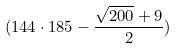Convert formula to latex. <formula><loc_0><loc_0><loc_500><loc_500>( 1 4 4 \cdot 1 8 5 - \frac { \sqrt { 2 0 0 } + 9 } { 2 } )</formula> 